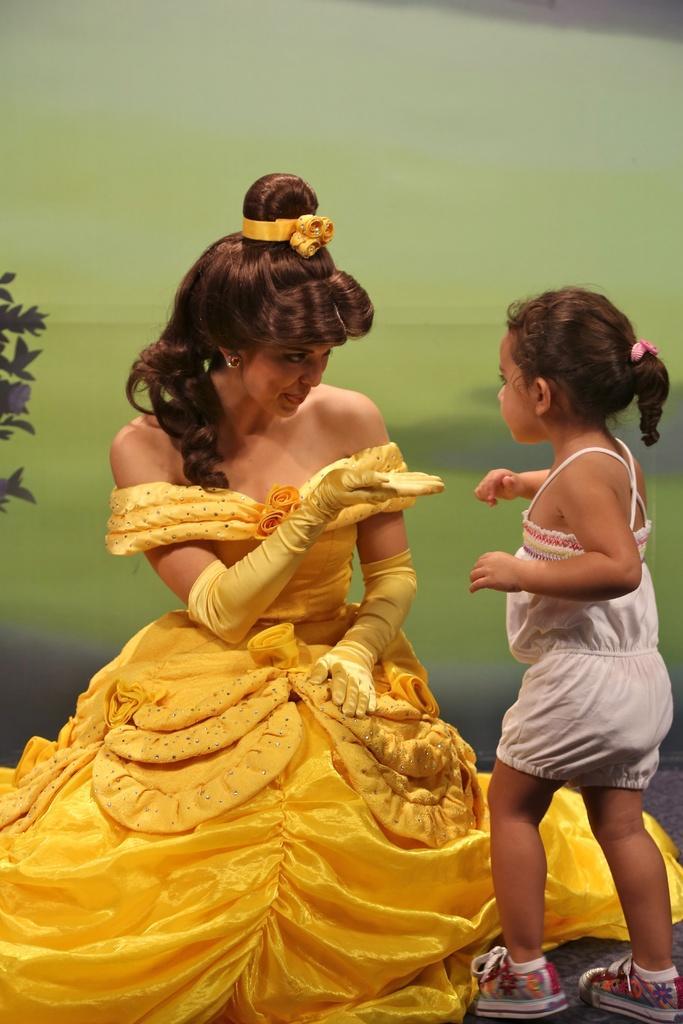How would you summarize this image in a sentence or two? In this image I can see two people with white and yellow color dresses. To the left I can see the plant. In the background I can see the green and grey color surface. 